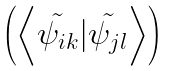<formula> <loc_0><loc_0><loc_500><loc_500>\begin{pmatrix} \left \langle \tilde { \psi _ { i k } } | \tilde { \psi _ { j l } } \right \rangle \end{pmatrix}</formula> 